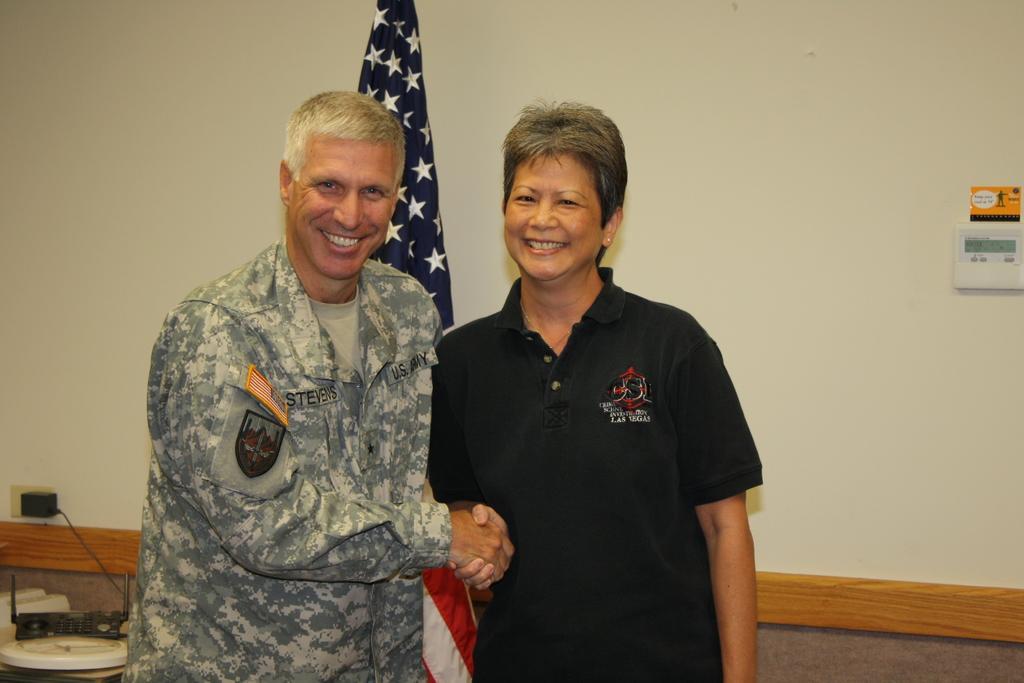Describe this image in one or two sentences. In this image there is a man and woman shaking their hands, in the background there is a table, on that table there are few objects and a flag and a wall. 